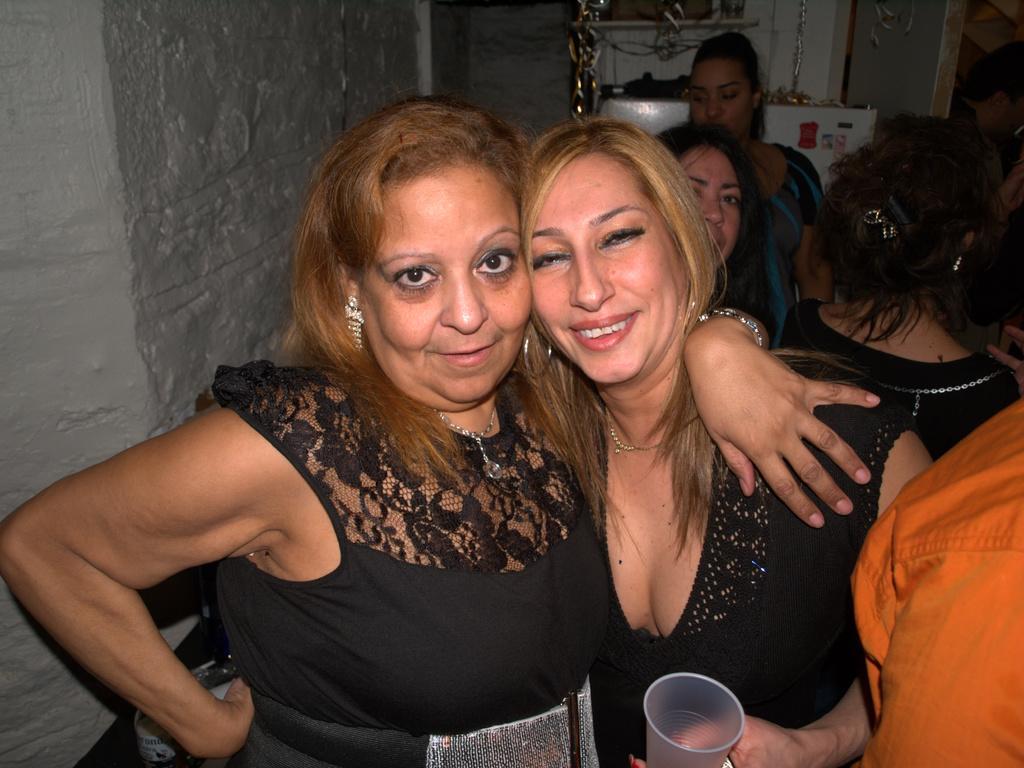Describe this image in one or two sentences. In this picture we can see some people standing, this woman is holding a glass, in the background there is a wall. 